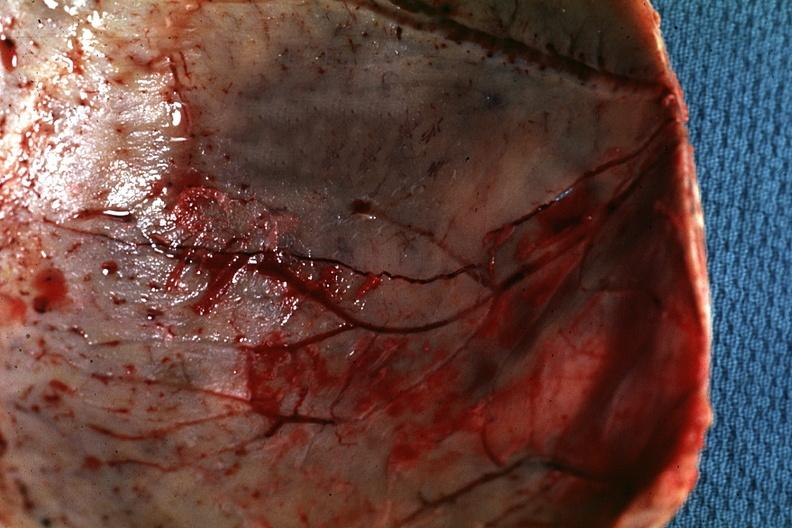s normal immature infant present?
Answer the question using a single word or phrase. No 